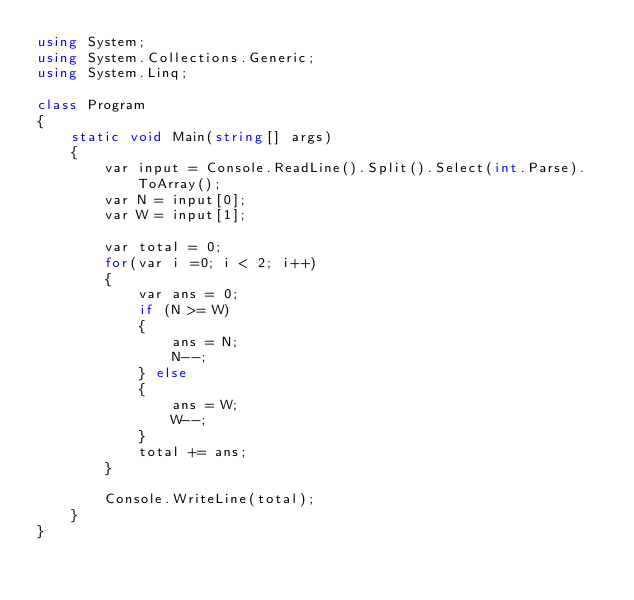<code> <loc_0><loc_0><loc_500><loc_500><_C#_>using System;
using System.Collections.Generic;
using System.Linq;

class Program
{
    static void Main(string[] args)
    {
        var input = Console.ReadLine().Split().Select(int.Parse).ToArray();
        var N = input[0];
        var W = input[1];

        var total = 0;
        for(var i =0; i < 2; i++)
        {
            var ans = 0;
            if (N >= W)
            {
                ans = N;
                N--;
            } else
            {
                ans = W;
                W--;
            }
            total += ans;
        }

        Console.WriteLine(total);
    }
}</code> 